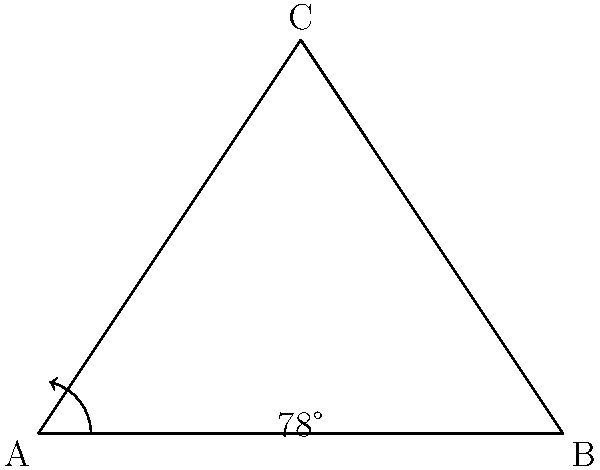In a tennis serve, the player stands at point A and aims to hit the ball over the net at point C. The ball lands at point B. If the angle between the ground and the initial trajectory of the ball is 78°, what is the angle of the ball's trajectory at point C (angle ACB)? To solve this problem, we'll use the properties of triangles:

1) In any triangle, the sum of all angles is 180°.

2) The angle at A is given as 78°.

3) We need to find angle ACB.

4) Let's call the angle at B as x°.

5) Now we can set up an equation:
   $78° + x° + ACB = 180°$

6) We know that AB is parallel to the ground, so the angle between AC and AB at A is also 78°.

7) This means that angle CAB is $180° - 78° = 102°$

8) In a right-angled triangle, the two non-right angles are complementary (they add up to 90°).

9) So, $x° + 78° = 90°$
   $x° = 12°$

10) Substituting this back into our equation from step 5:
    $78° + 12° + ACB = 180°$
    $90° + ACB = 180°$
    $ACB = 90°$

Therefore, the angle of the ball's trajectory at point C (angle ACB) is 90°.
Answer: $90°$ 